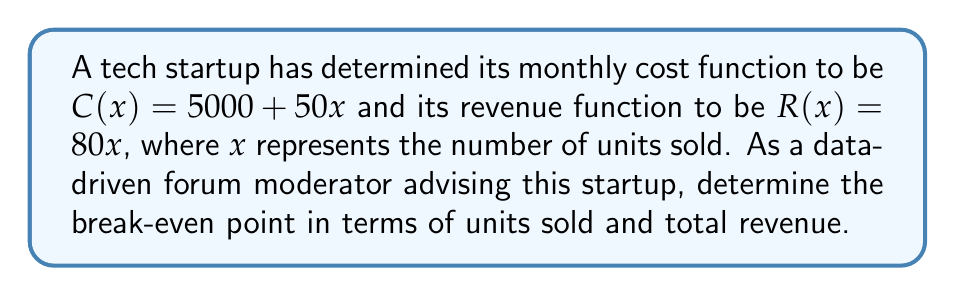What is the answer to this math problem? To find the break-even point, we need to determine where the cost function equals the revenue function. Let's solve this step-by-step:

1) Set up the equation:
   $$C(x) = R(x)$$
   $$5000 + 50x = 80x$$

2) Solve for x:
   $$5000 = 80x - 50x$$
   $$5000 = 30x$$
   $$x = \frac{5000}{30} = 166.67$$

   Since we can't sell a fraction of a unit, we round up to 167 units.

3) Calculate the break-even revenue:
   $$R(167) = 80 * 167 = 13,360$$

Therefore, the break-even point occurs when the startup sells 167 units, generating $13,360 in revenue.

To verify:
$$C(167) = 5000 + 50(167) = 13,350$$
$$R(167) = 80(167) = 13,360$$

The slight difference ($10) is due to rounding up the number of units.
Answer: 167 units; $13,360 revenue 